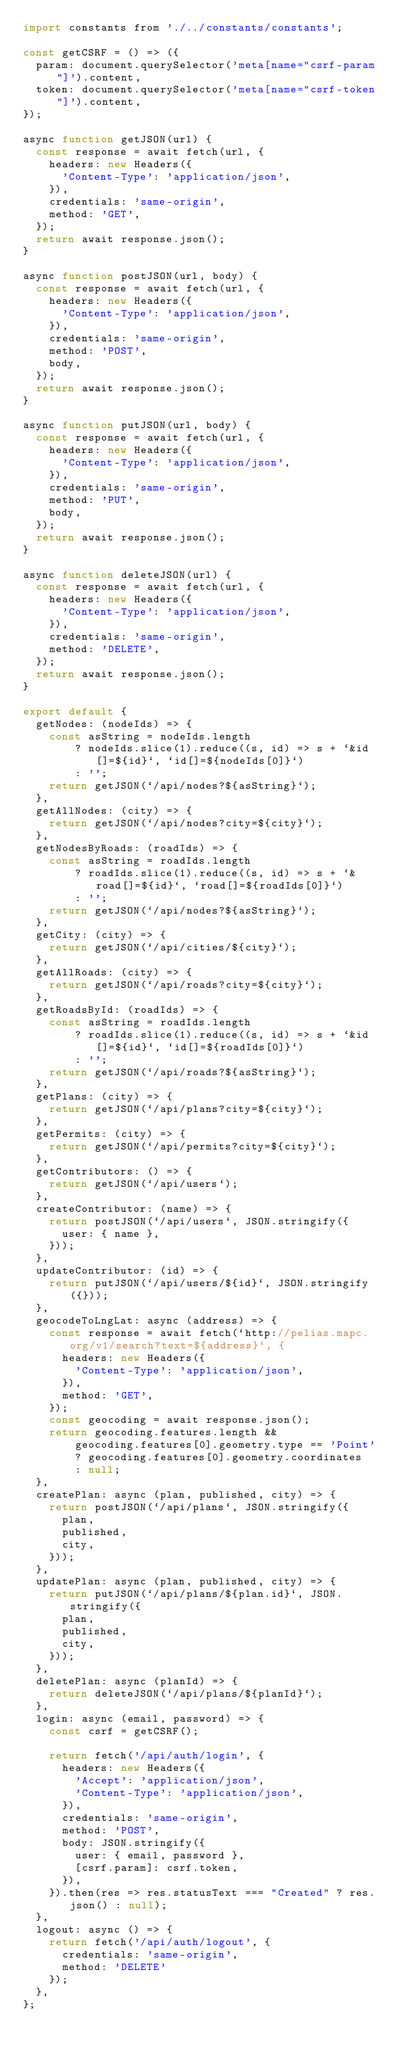Convert code to text. <code><loc_0><loc_0><loc_500><loc_500><_JavaScript_>import constants from './../constants/constants';

const getCSRF = () => ({
  param: document.querySelector('meta[name="csrf-param"]').content,
  token: document.querySelector('meta[name="csrf-token"]').content,
});

async function getJSON(url) {
  const response = await fetch(url, {
    headers: new Headers({
      'Content-Type': 'application/json',
    }),
    credentials: 'same-origin',
    method: 'GET',
  });
  return await response.json();
}

async function postJSON(url, body) {
  const response = await fetch(url, {
    headers: new Headers({
      'Content-Type': 'application/json',
    }),
    credentials: 'same-origin',
    method: 'POST',
    body,
  });
  return await response.json();
}

async function putJSON(url, body) {
  const response = await fetch(url, {
    headers: new Headers({
      'Content-Type': 'application/json',
    }),
    credentials: 'same-origin',
    method: 'PUT',
    body,
  });
  return await response.json();
}

async function deleteJSON(url) {
  const response = await fetch(url, {
    headers: new Headers({
      'Content-Type': 'application/json',
    }),
    credentials: 'same-origin',
    method: 'DELETE',
  });
  return await response.json();
}

export default {
  getNodes: (nodeIds) => {
    const asString = nodeIds.length
        ? nodeIds.slice(1).reduce((s, id) => s + `&id[]=${id}`, `id[]=${nodeIds[0]}`)
        : '';
    return getJSON(`/api/nodes?${asString}`);
  },
  getAllNodes: (city) => {
    return getJSON(`/api/nodes?city=${city}`);
  },
  getNodesByRoads: (roadIds) => {
    const asString = roadIds.length
        ? roadIds.slice(1).reduce((s, id) => s + `&road[]=${id}`, `road[]=${roadIds[0]}`)
        : '';
    return getJSON(`/api/nodes?${asString}`);
  },
  getCity: (city) => {
    return getJSON(`/api/cities/${city}`);
  },
  getAllRoads: (city) => {
    return getJSON(`/api/roads?city=${city}`);
  },
  getRoadsById: (roadIds) => {
    const asString = roadIds.length
        ? roadIds.slice(1).reduce((s, id) => s + `&id[]=${id}`, `id[]=${roadIds[0]}`)
        : '';
    return getJSON(`/api/roads?${asString}`);
  },
  getPlans: (city) => {
    return getJSON(`/api/plans?city=${city}`);
  },
  getPermits: (city) => {
    return getJSON(`/api/permits?city=${city}`);
  },
  getContributors: () => {
    return getJSON(`/api/users`);
  },
  createContributor: (name) => {
    return postJSON(`/api/users`, JSON.stringify({
      user: { name },
    }));
  },
  updateContributor: (id) => {
    return putJSON(`/api/users/${id}`, JSON.stringify({}));
  },
  geocodeToLngLat: async (address) => {
    const response = await fetch(`http://pelias.mapc.org/v1/search?text=${address}`, {
      headers: new Headers({
        'Content-Type': 'application/json',
      }),
      method: 'GET',
    });
    const geocoding = await response.json();
    return geocoding.features.length &&
        geocoding.features[0].geometry.type == 'Point'
        ? geocoding.features[0].geometry.coordinates
        : null;
  },
  createPlan: async (plan, published, city) => {
    return postJSON(`/api/plans`, JSON.stringify({
      plan,
      published,
      city,
    }));
  },
  updatePlan: async (plan, published, city) => {
    return putJSON(`/api/plans/${plan.id}`, JSON.stringify({
      plan,
      published,
      city,
    }));
  },
  deletePlan: async (planId) => {
    return deleteJSON(`/api/plans/${planId}`);
  },
  login: async (email, password) => {
    const csrf = getCSRF();

    return fetch('/api/auth/login', {
      headers: new Headers({
        'Accept': 'application/json',
        'Content-Type': 'application/json',
      }),
      credentials: 'same-origin',
      method: 'POST',
      body: JSON.stringify({
        user: { email, password },
        [csrf.param]: csrf.token,
      }),
    }).then(res => res.statusText === "Created" ? res.json() : null);
  },
  logout: async () => {
    return fetch('/api/auth/logout', {
      credentials: 'same-origin',
      method: 'DELETE'
    });
  },
};
</code> 